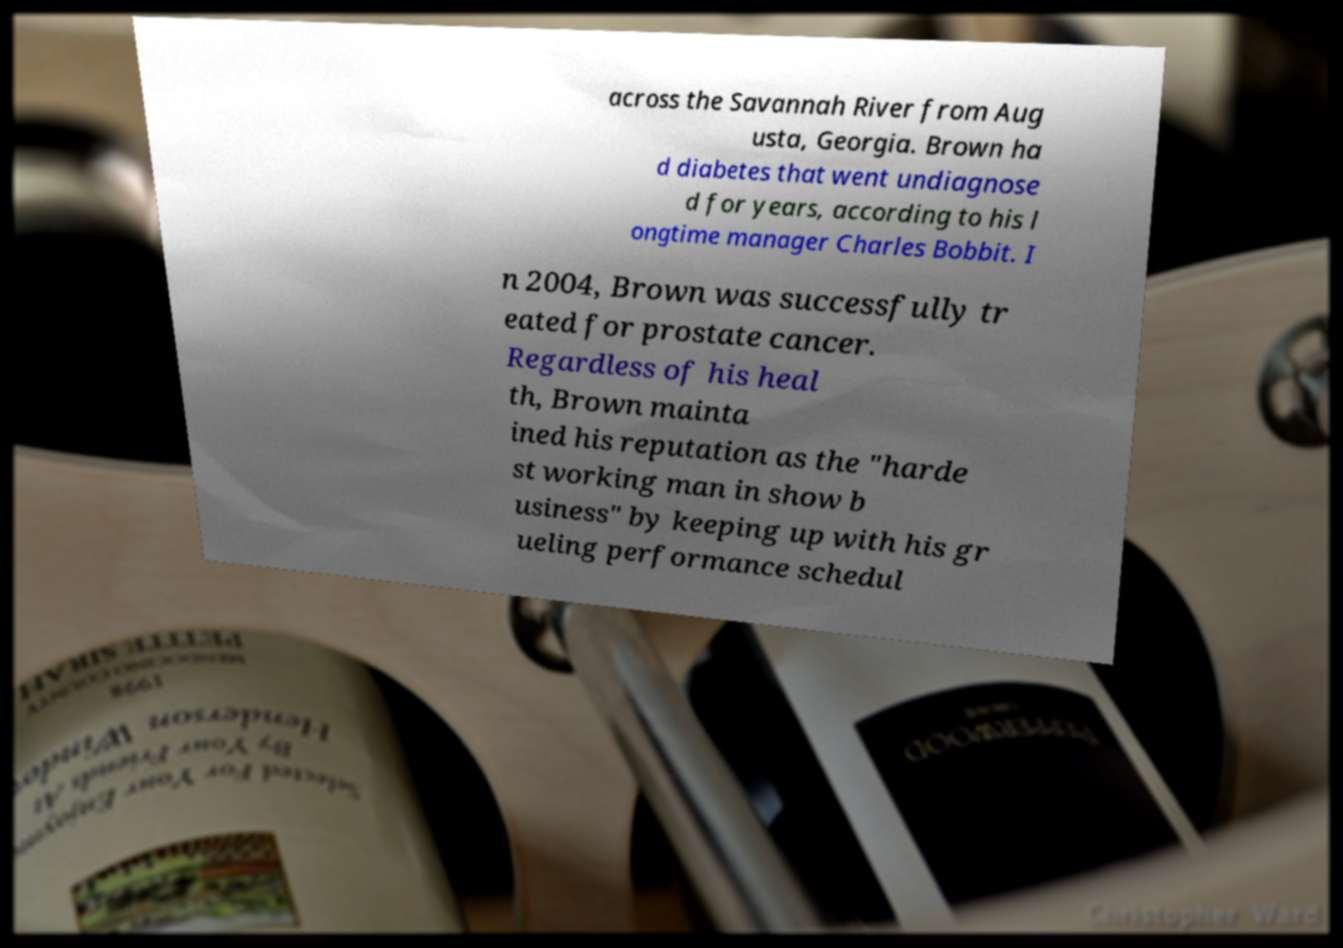What messages or text are displayed in this image? I need them in a readable, typed format. across the Savannah River from Aug usta, Georgia. Brown ha d diabetes that went undiagnose d for years, according to his l ongtime manager Charles Bobbit. I n 2004, Brown was successfully tr eated for prostate cancer. Regardless of his heal th, Brown mainta ined his reputation as the "harde st working man in show b usiness" by keeping up with his gr ueling performance schedul 